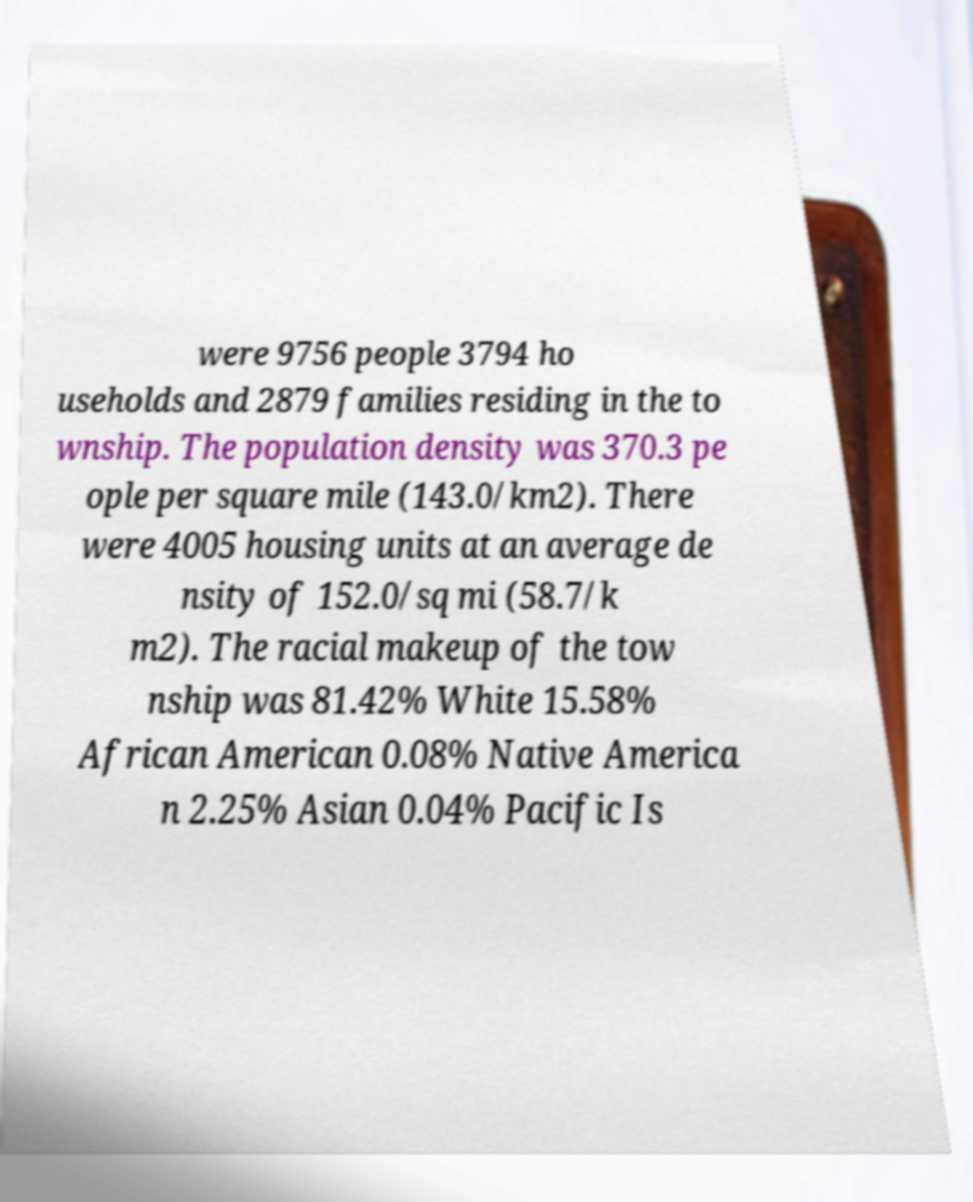Can you read and provide the text displayed in the image?This photo seems to have some interesting text. Can you extract and type it out for me? were 9756 people 3794 ho useholds and 2879 families residing in the to wnship. The population density was 370.3 pe ople per square mile (143.0/km2). There were 4005 housing units at an average de nsity of 152.0/sq mi (58.7/k m2). The racial makeup of the tow nship was 81.42% White 15.58% African American 0.08% Native America n 2.25% Asian 0.04% Pacific Is 